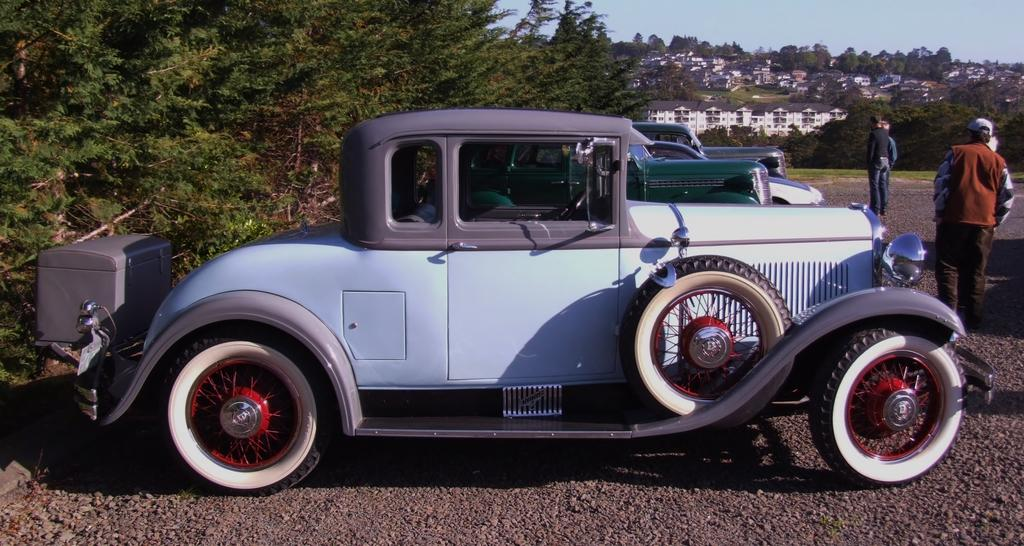What can be seen in the image involving people? There are people standing in the image. What else is present in the image besides people? There are vehicles, buildings, trees, and the sky visible in the image. Can you describe the vehicles in the image? Unfortunately, the facts provided do not give specific details about the vehicles. What type of vegetation is present in the image? There are trees in the image. What type of rhythm can be heard coming from the cave in the image? There is no cave present in the image, so it's not possible to determine what, if any, rhythm might be heard. 